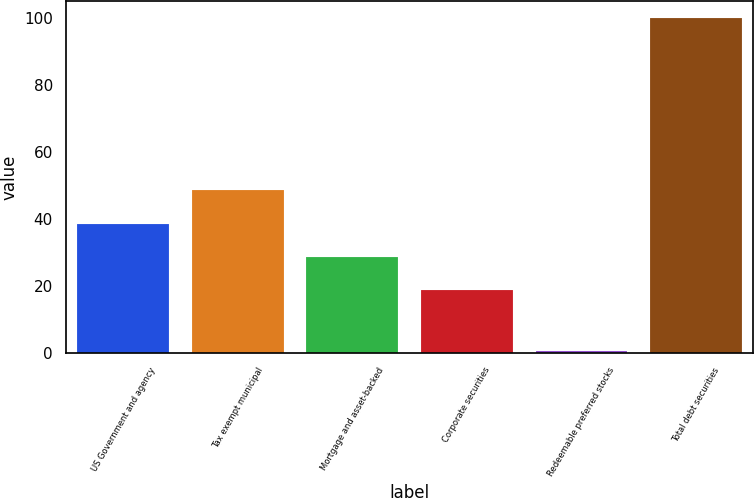Convert chart. <chart><loc_0><loc_0><loc_500><loc_500><bar_chart><fcel>US Government and agency<fcel>Tax exempt municipal<fcel>Mortgage and asset-backed<fcel>Corporate securities<fcel>Redeemable preferred stocks<fcel>Total debt securities<nl><fcel>38.52<fcel>48.48<fcel>28.56<fcel>18.6<fcel>0.4<fcel>100<nl></chart> 